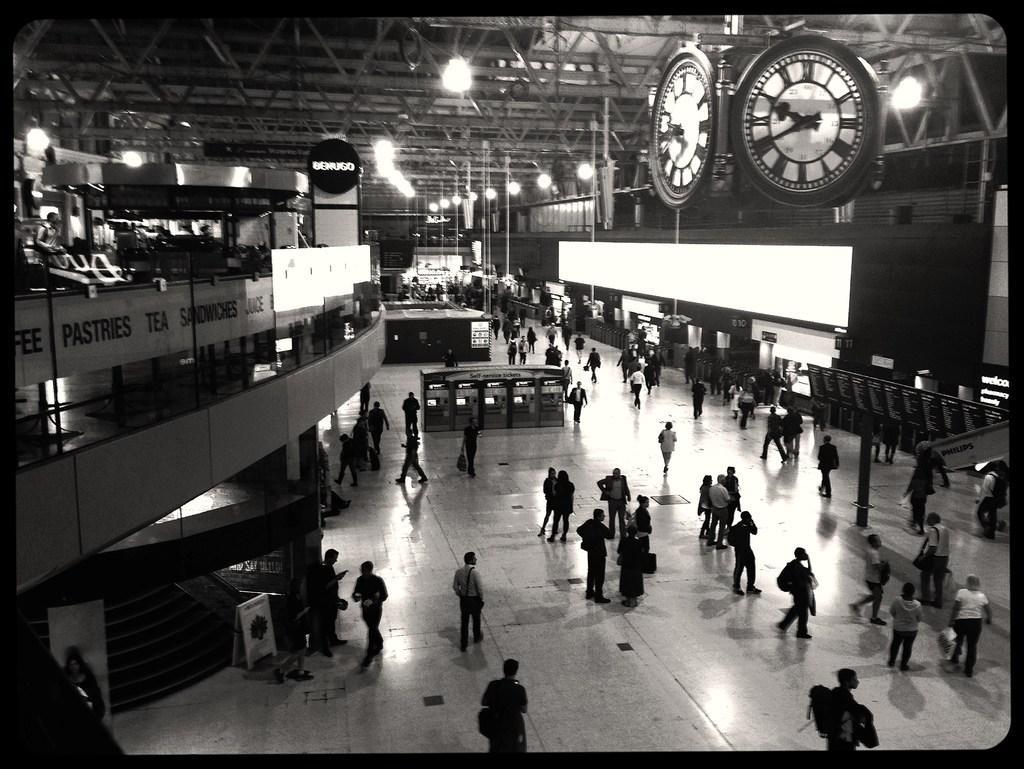How would you summarize this image in a sentence or two? In this image at the bottom, there are many people, posters. In the middle there are clocks, lights, posters, some people, text, poles and roof. 